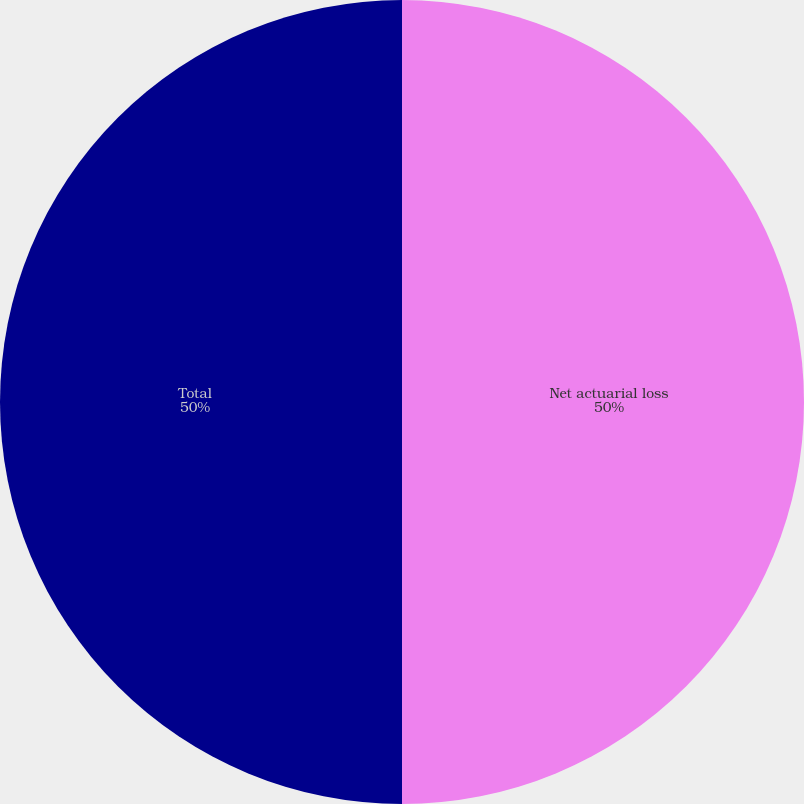<chart> <loc_0><loc_0><loc_500><loc_500><pie_chart><fcel>Net actuarial loss<fcel>Total<nl><fcel>50.0%<fcel>50.0%<nl></chart> 